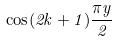<formula> <loc_0><loc_0><loc_500><loc_500>\cos ( 2 k + 1 ) \frac { \pi y } { 2 }</formula> 